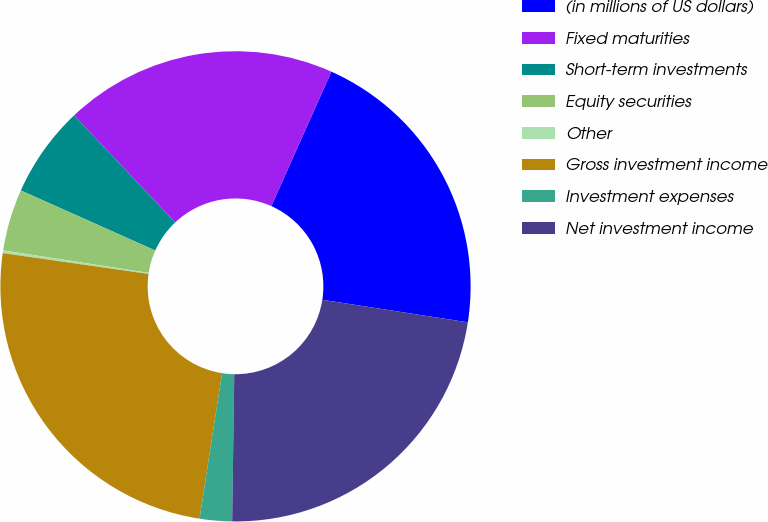<chart> <loc_0><loc_0><loc_500><loc_500><pie_chart><fcel>(in millions of US dollars)<fcel>Fixed maturities<fcel>Short-term investments<fcel>Equity securities<fcel>Other<fcel>Gross investment income<fcel>Investment expenses<fcel>Net investment income<nl><fcel>20.76%<fcel>18.73%<fcel>6.27%<fcel>4.24%<fcel>0.19%<fcel>24.81%<fcel>2.22%<fcel>22.78%<nl></chart> 